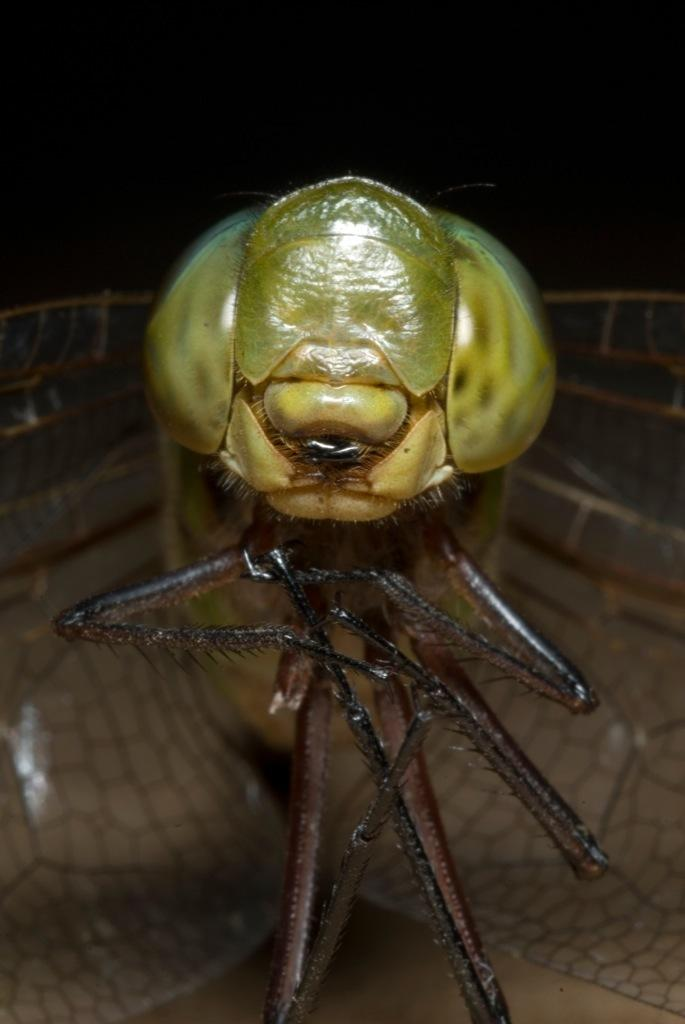What is present in the image that could be interpreted as "fly"? There is something in the image that could be interpreted as "fly." What advice does the fly give to the person in the image? There is no person present in the image, and the fly does not give any advice, as it is not a living creature capable of providing advice. 